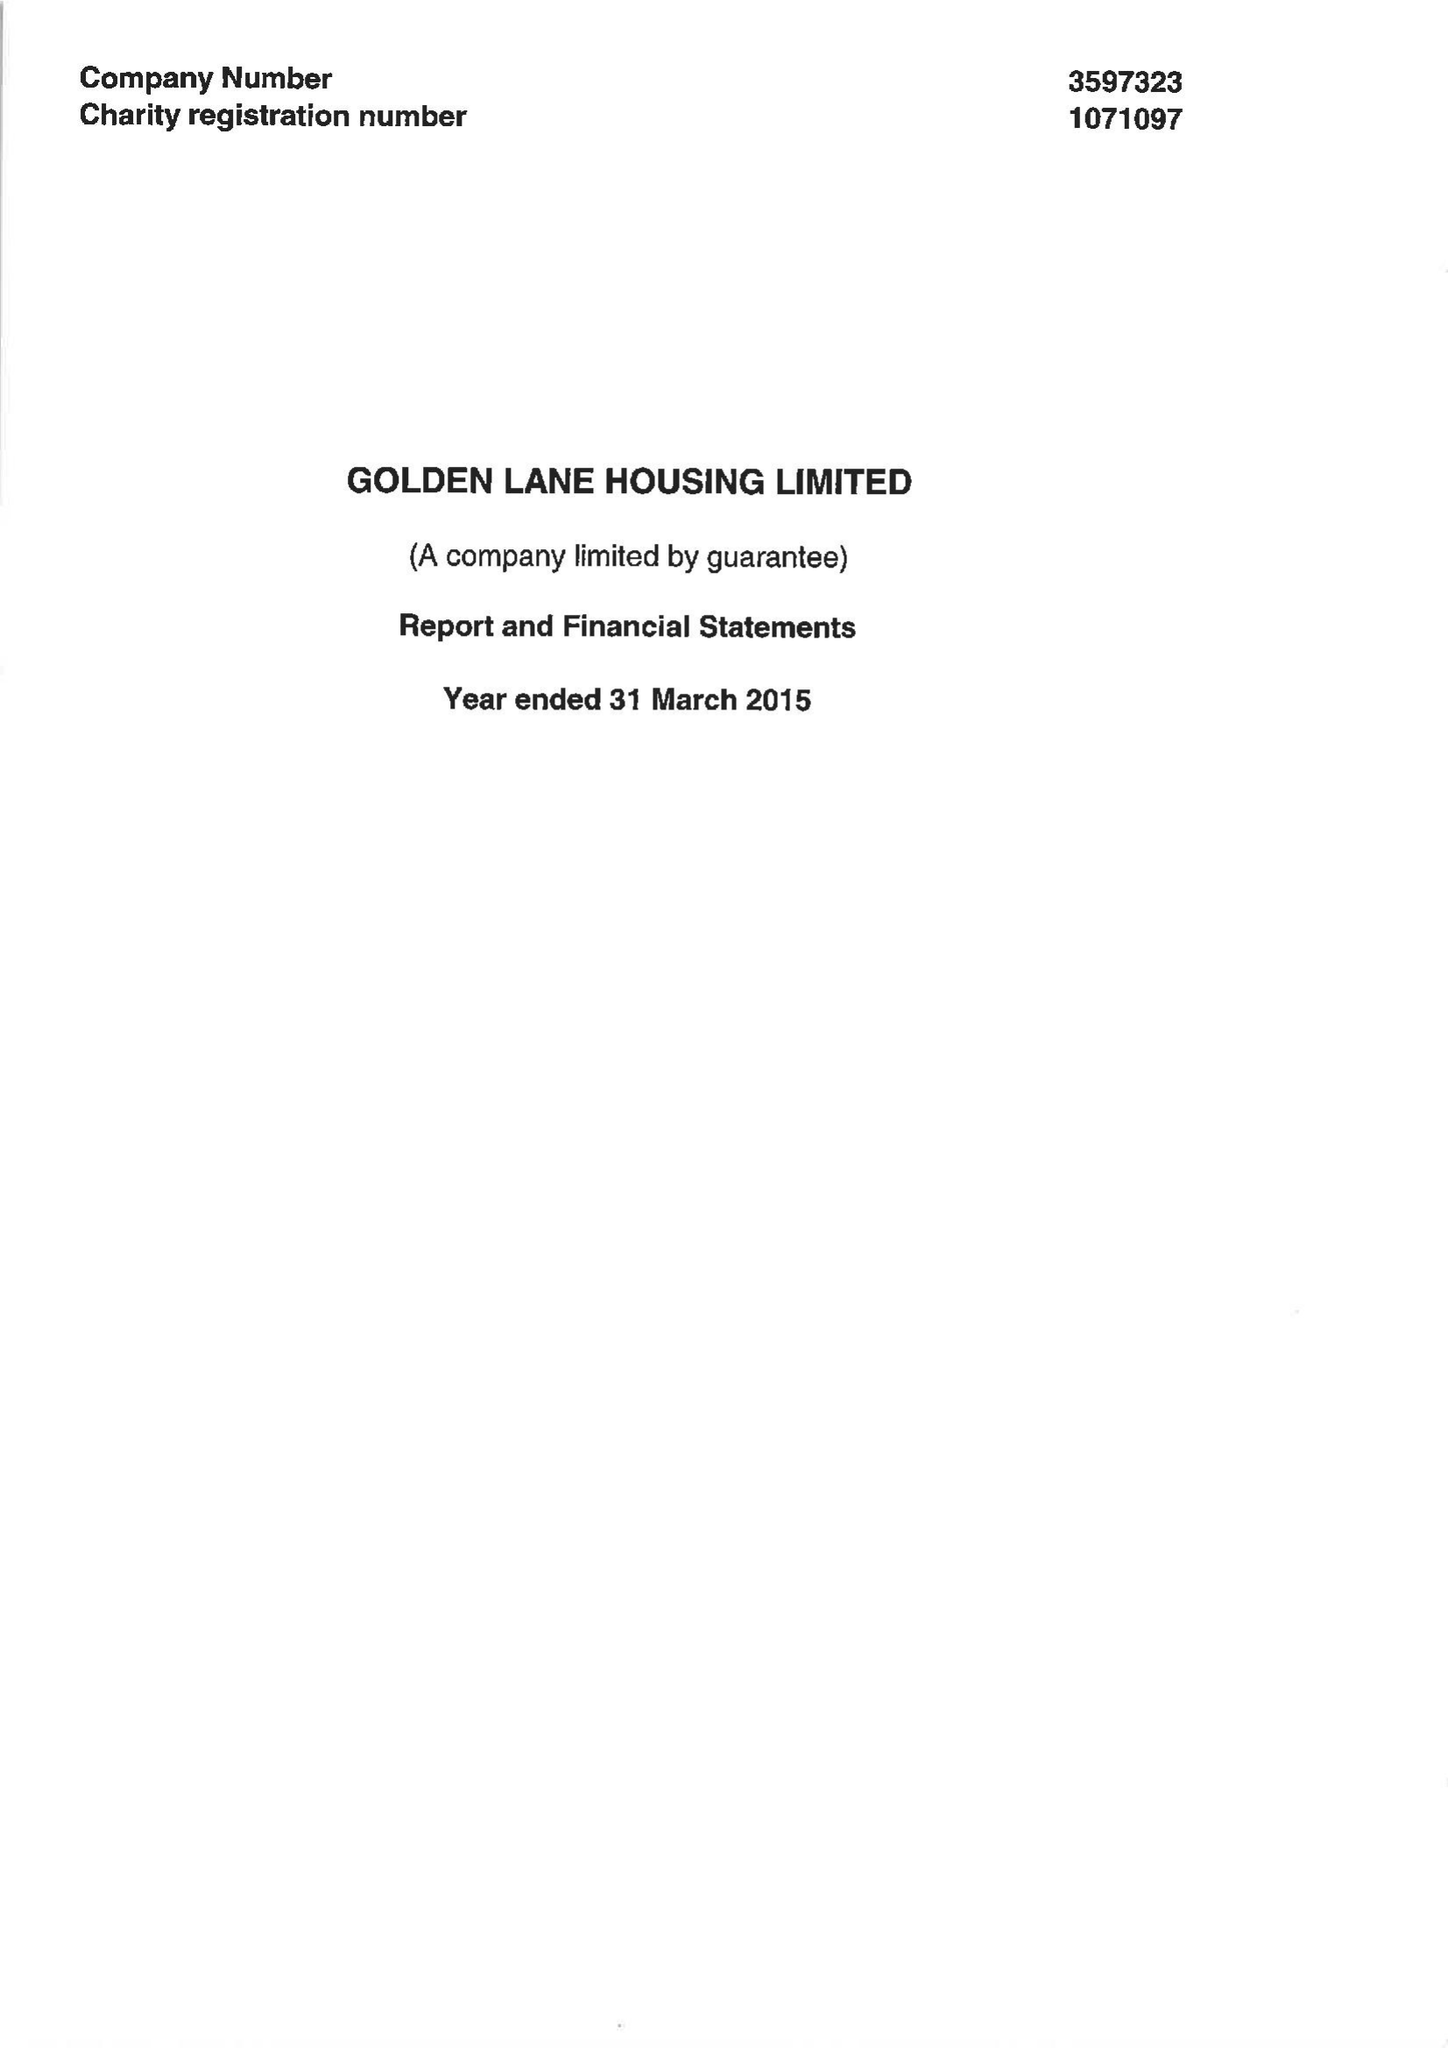What is the value for the address__post_town?
Answer the question using a single word or phrase. LONDON 